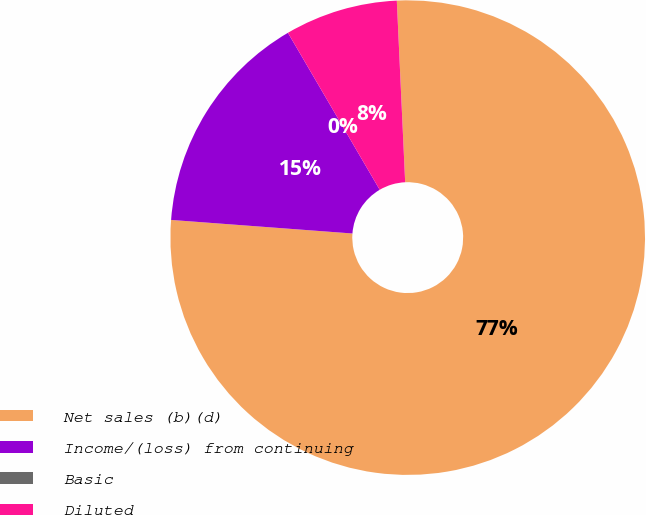Convert chart to OTSL. <chart><loc_0><loc_0><loc_500><loc_500><pie_chart><fcel>Net sales (b)(d)<fcel>Income/(loss) from continuing<fcel>Basic<fcel>Diluted<nl><fcel>76.92%<fcel>15.39%<fcel>0.0%<fcel>7.69%<nl></chart> 